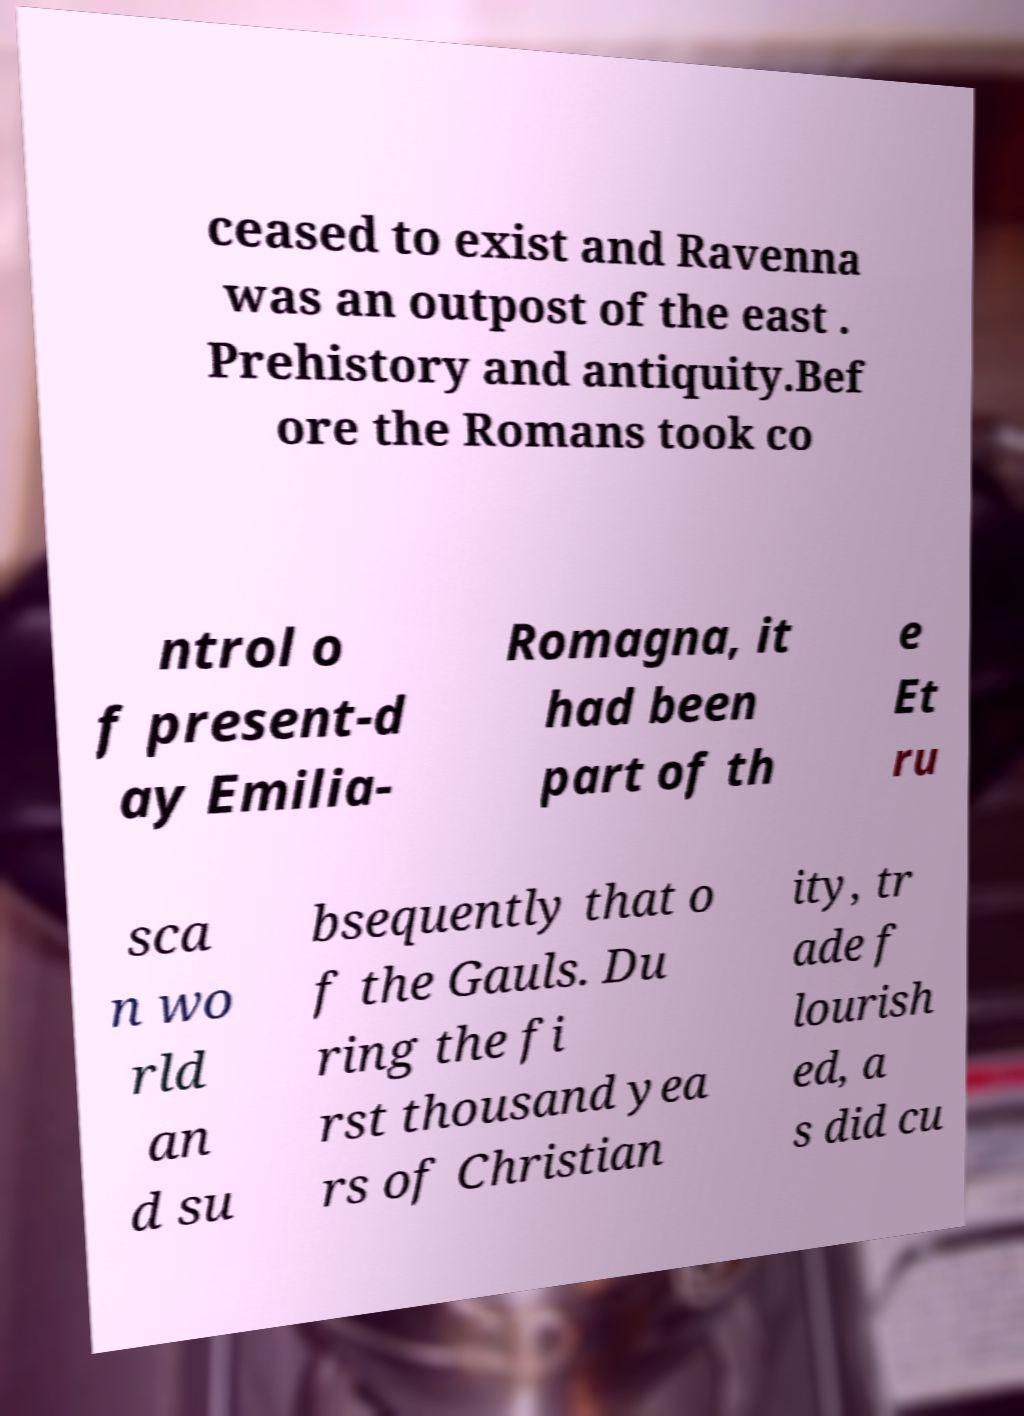There's text embedded in this image that I need extracted. Can you transcribe it verbatim? ceased to exist and Ravenna was an outpost of the east . Prehistory and antiquity.Bef ore the Romans took co ntrol o f present-d ay Emilia- Romagna, it had been part of th e Et ru sca n wo rld an d su bsequently that o f the Gauls. Du ring the fi rst thousand yea rs of Christian ity, tr ade f lourish ed, a s did cu 